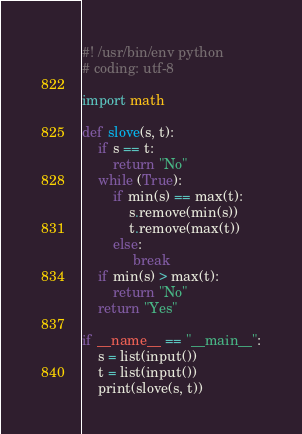<code> <loc_0><loc_0><loc_500><loc_500><_Python_>#! /usr/bin/env python
# coding: utf-8

import math

def slove(s, t):
    if s == t:
        return "No"
    while (True):
        if min(s) == max(t):
            s.remove(min(s))
            t.remove(max(t))
        else:
             break
    if min(s) > max(t):
        return "No"
    return "Yes"

if __name__ == "__main__":
    s = list(input())
    t = list(input())
    print(slove(s, t))</code> 